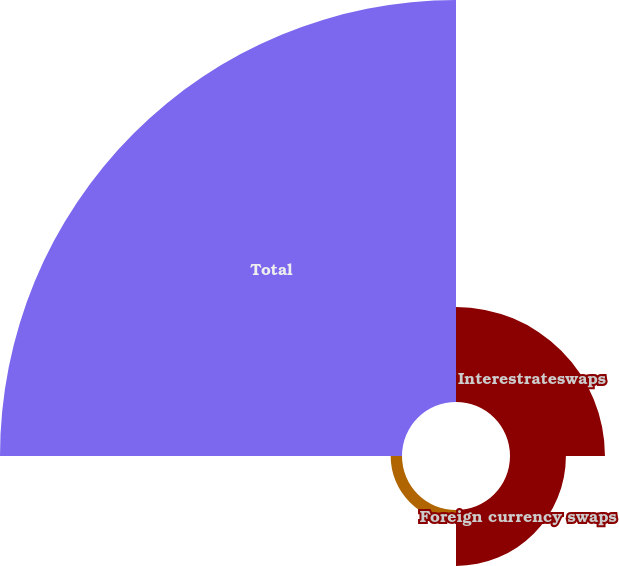Convert chart. <chart><loc_0><loc_0><loc_500><loc_500><pie_chart><fcel>Interestrateswaps<fcel>Foreign currency swaps<fcel>Credit default swaps<fcel>Total<nl><fcel>16.83%<fcel>9.91%<fcel>2.01%<fcel>71.24%<nl></chart> 